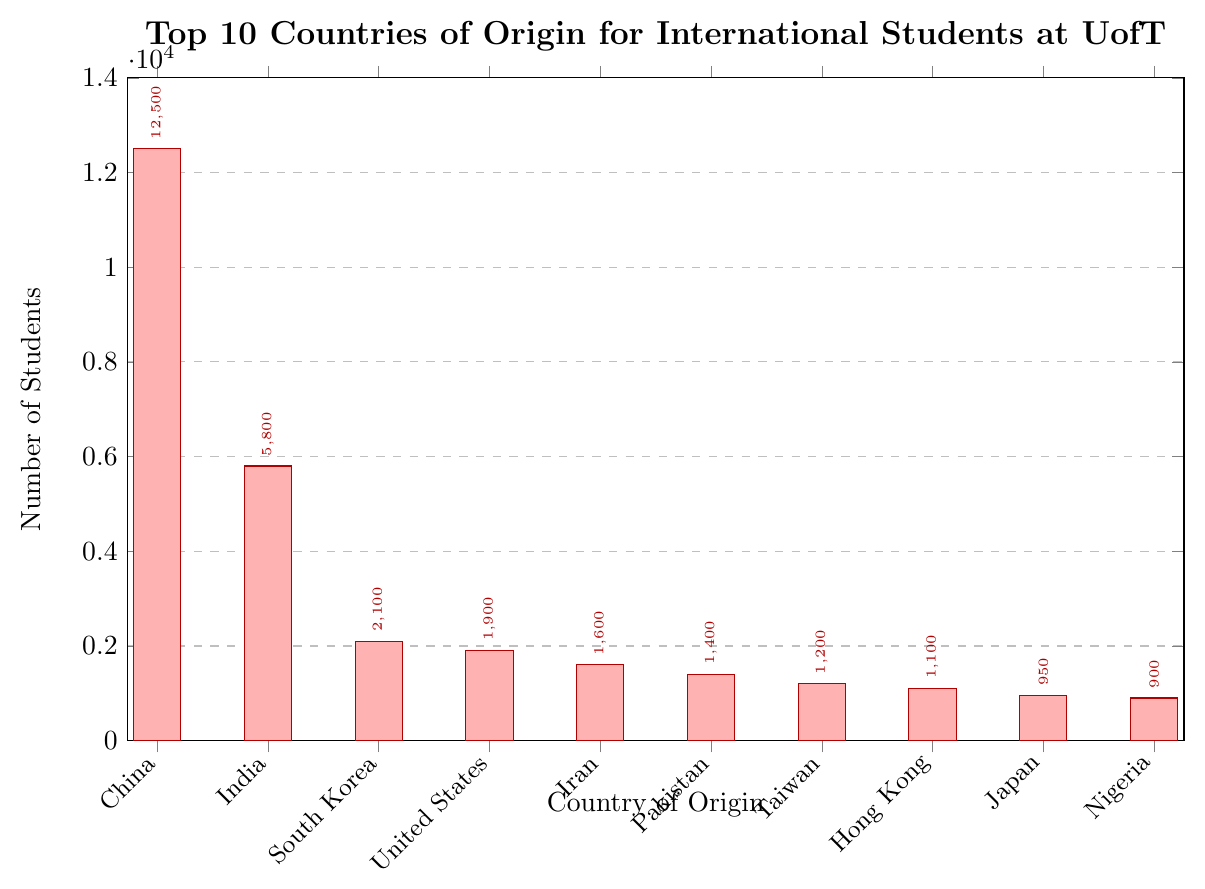What is the total number of students from China, India, and South Korea? Sum the individual numbers of students from China (12,500), India (5,800), and South Korea (2,100). 12,500 + 5,800 + 2,100 = 20,400
Answer: 20,400 Which country has the second highest number of students? The bar chart shows numbers decreasing from China to Nigeria. India is the second bar, and it has 5,800 students.
Answer: India How many more students are there from Iran compared to Nigeria? The number of students from Iran is 1,600, and from Nigeria is 900. Subtract 900 from 1,600. 1,600 - 900 = 700
Answer: 700 What is the average number of students from the top 10 countries? Sum the numbers of students from the top 10 countries, then divide by 10. (12,500 + 5,800 + 2,100 + 1,900 + 1,600 + 1,400 + 1,200 + 1,100 + 950 + 900) / 10 = 29,450 / 10 = 2,945
Answer: 2,945 What is the difference in student numbers between the country with the most students and the country with the least students (from the top 10)? The country with the most students is China (12,500), and the country with the least students in the top 10 is Nigeria (900). Subtract 900 from 12,500. 12,500 - 900 = 11,600
Answer: 11,600 Which two countries have the closest number of students? Compare the values and find the two that are numerically closest. Taiwan (1,200) and Hong Kong (1,100) differ by 100 students, which is the smallest difference.
Answer: Taiwan and Hong Kong What is the combined number of students from the United States, Iran, and Pakistan? Add the number of students from the United States (1,900), Iran (1,600), and Pakistan (1,400). 1,900 + 1,600 + 1,400 = 4,900
Answer: 4,900 Which bar has the highest height? By examining the bar heights, the one representing China stands tallest.
Answer: China How does the number of students from South Korea compare to the number from Japan plus Nigeria? The number of students from South Korea is 2,100. The combined number from Japan (950) and Nigeria (900) is 950 + 900 = 1,850. South Korea has more.
Answer: South Korea has more 